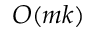<formula> <loc_0><loc_0><loc_500><loc_500>O ( m k )</formula> 